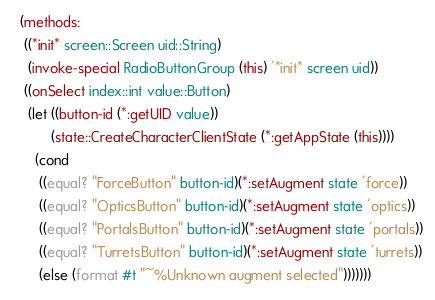Convert code to text. <code><loc_0><loc_0><loc_500><loc_500><_Scheme_>  (methods:
   ((*init* screen::Screen uid::String)
    (invoke-special RadioButtonGroup (this) '*init* screen uid))
   ((onSelect index::int value::Button)
    (let ((button-id (*:getUID value))
          (state::CreateCharacterClientState (*:getAppState (this))))
      (cond
       ((equal? "ForceButton" button-id)(*:setAugment state 'force))
       ((equal? "OpticsButton" button-id)(*:setAugment state 'optics))
       ((equal? "PortalsButton" button-id)(*:setAugment state 'portals))
       ((equal? "TurretsButton" button-id)(*:setAugment state 'turrets))
       (else (format #t "~%Unknown augment selected")))))))
</code> 